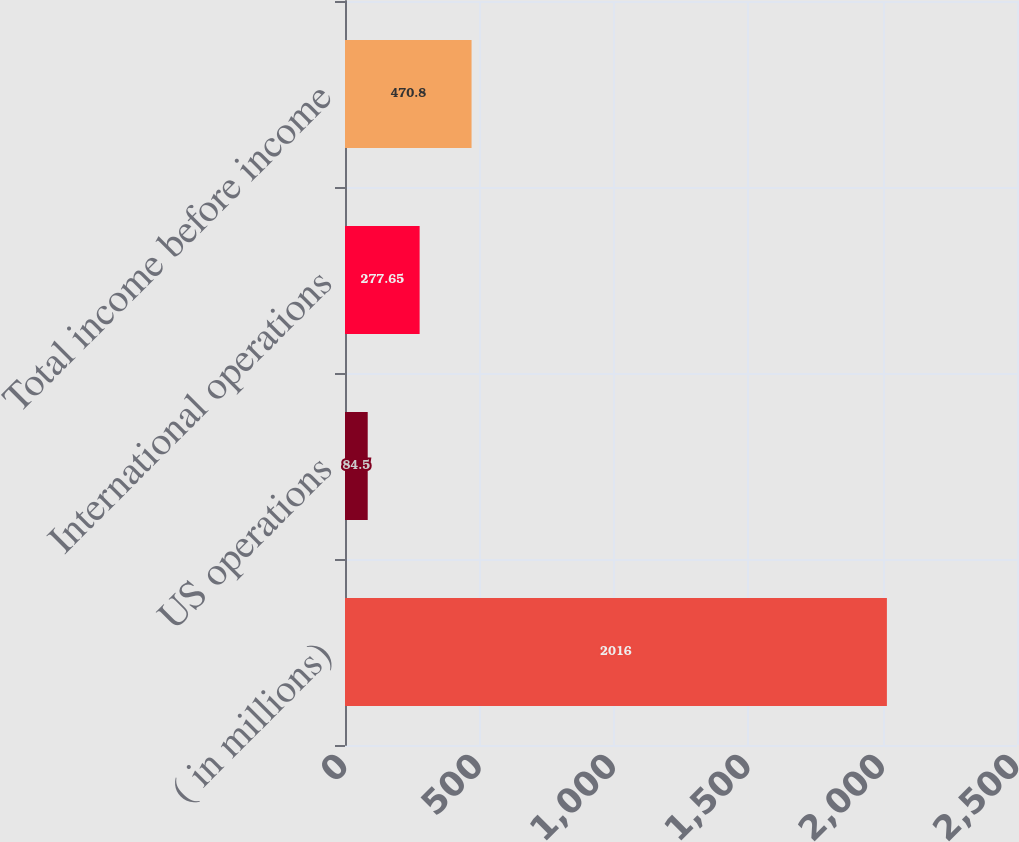<chart> <loc_0><loc_0><loc_500><loc_500><bar_chart><fcel>( in millions)<fcel>US operations<fcel>International operations<fcel>Total income before income<nl><fcel>2016<fcel>84.5<fcel>277.65<fcel>470.8<nl></chart> 